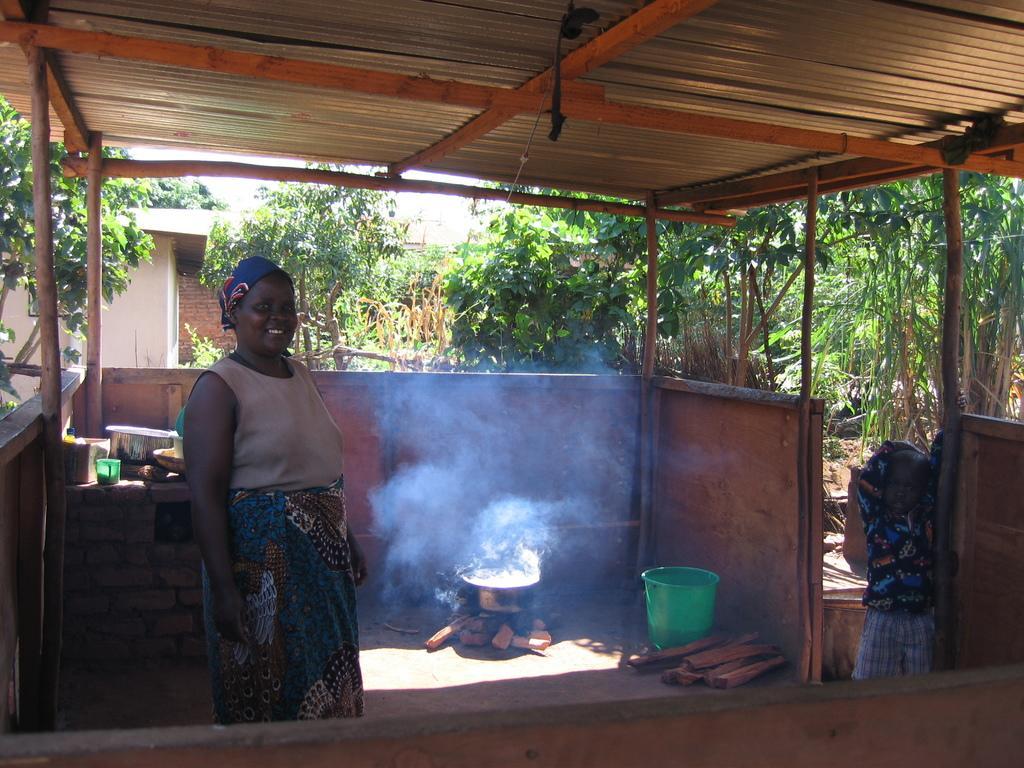Could you give a brief overview of what you see in this image? In this image there is a woman standing. Behind her there are a few objects on the table. Beside it there is a fireplace. There is an utensil on the fireplace. Beside it there are wood pieces and a bucket. To the right there there is a kid standing. In the background there are trees, plants and a house. At the top there is a ceiling of the shed. 